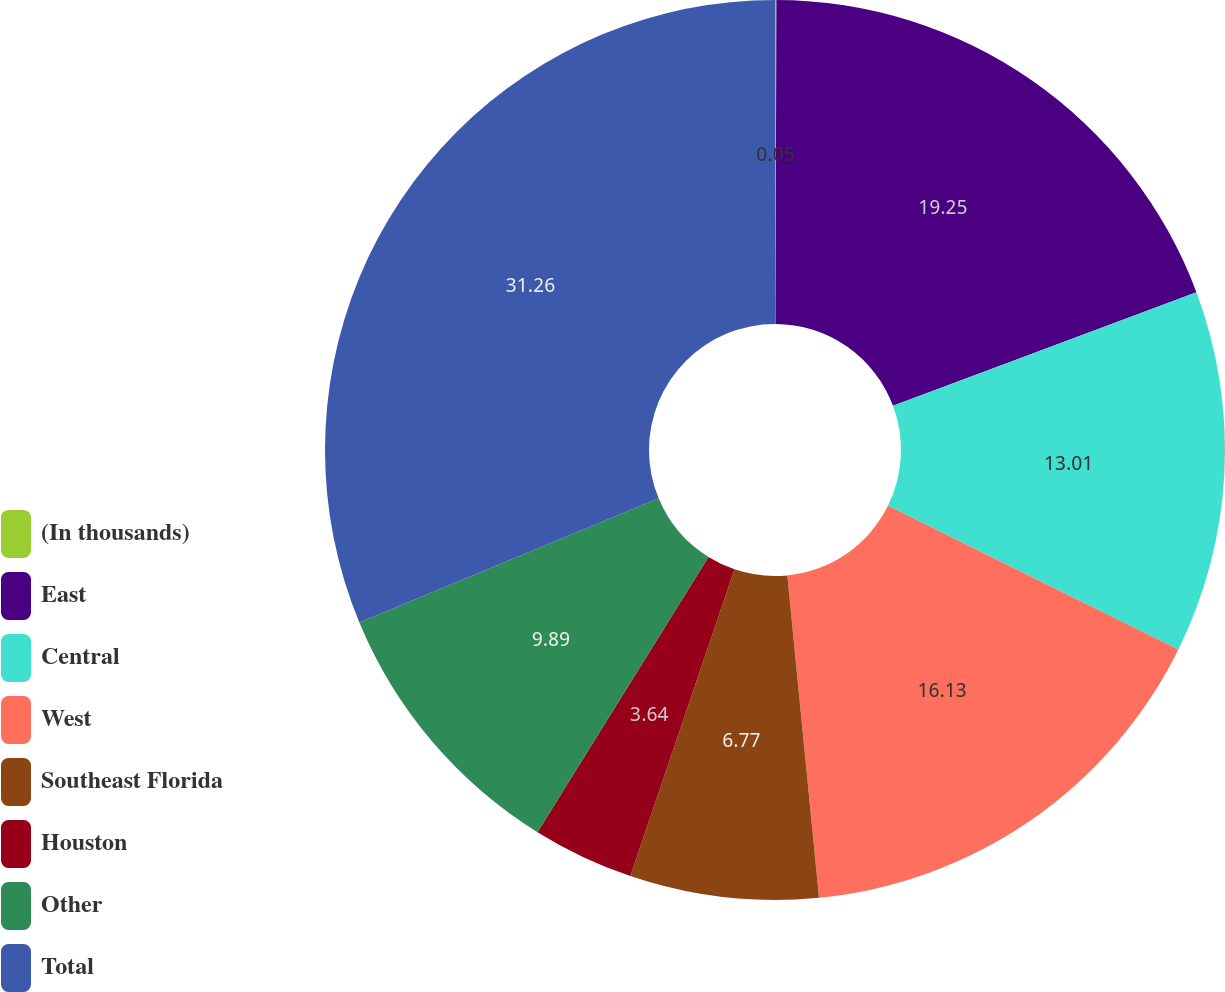<chart> <loc_0><loc_0><loc_500><loc_500><pie_chart><fcel>(In thousands)<fcel>East<fcel>Central<fcel>West<fcel>Southeast Florida<fcel>Houston<fcel>Other<fcel>Total<nl><fcel>0.05%<fcel>19.25%<fcel>13.01%<fcel>16.13%<fcel>6.77%<fcel>3.64%<fcel>9.89%<fcel>31.26%<nl></chart> 